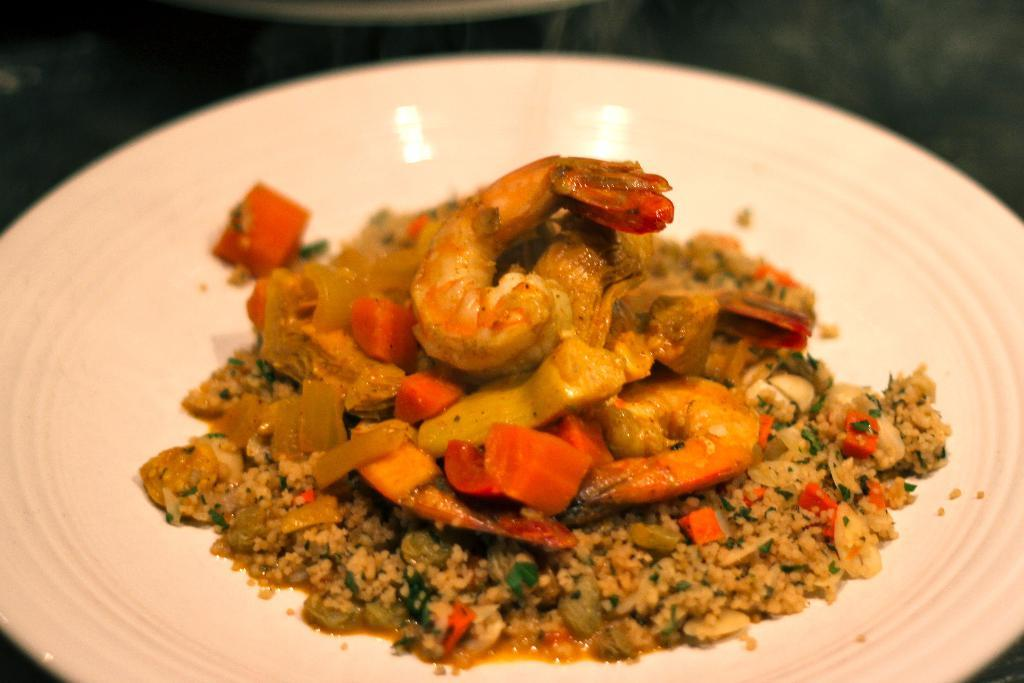What is the main subject of the image? The main subject of the image is a plate served with food. Can you describe the food on the plate? Unfortunately, the specific type of food on the plate cannot be determined from the provided fact. What might be used to consume the food on the plate? Utensils, such as a fork or spoon, might be used to consume the food on the plate. What musical instrument is being played in the image? There is no musical instrument present in the image; it only features a plate served with food. 